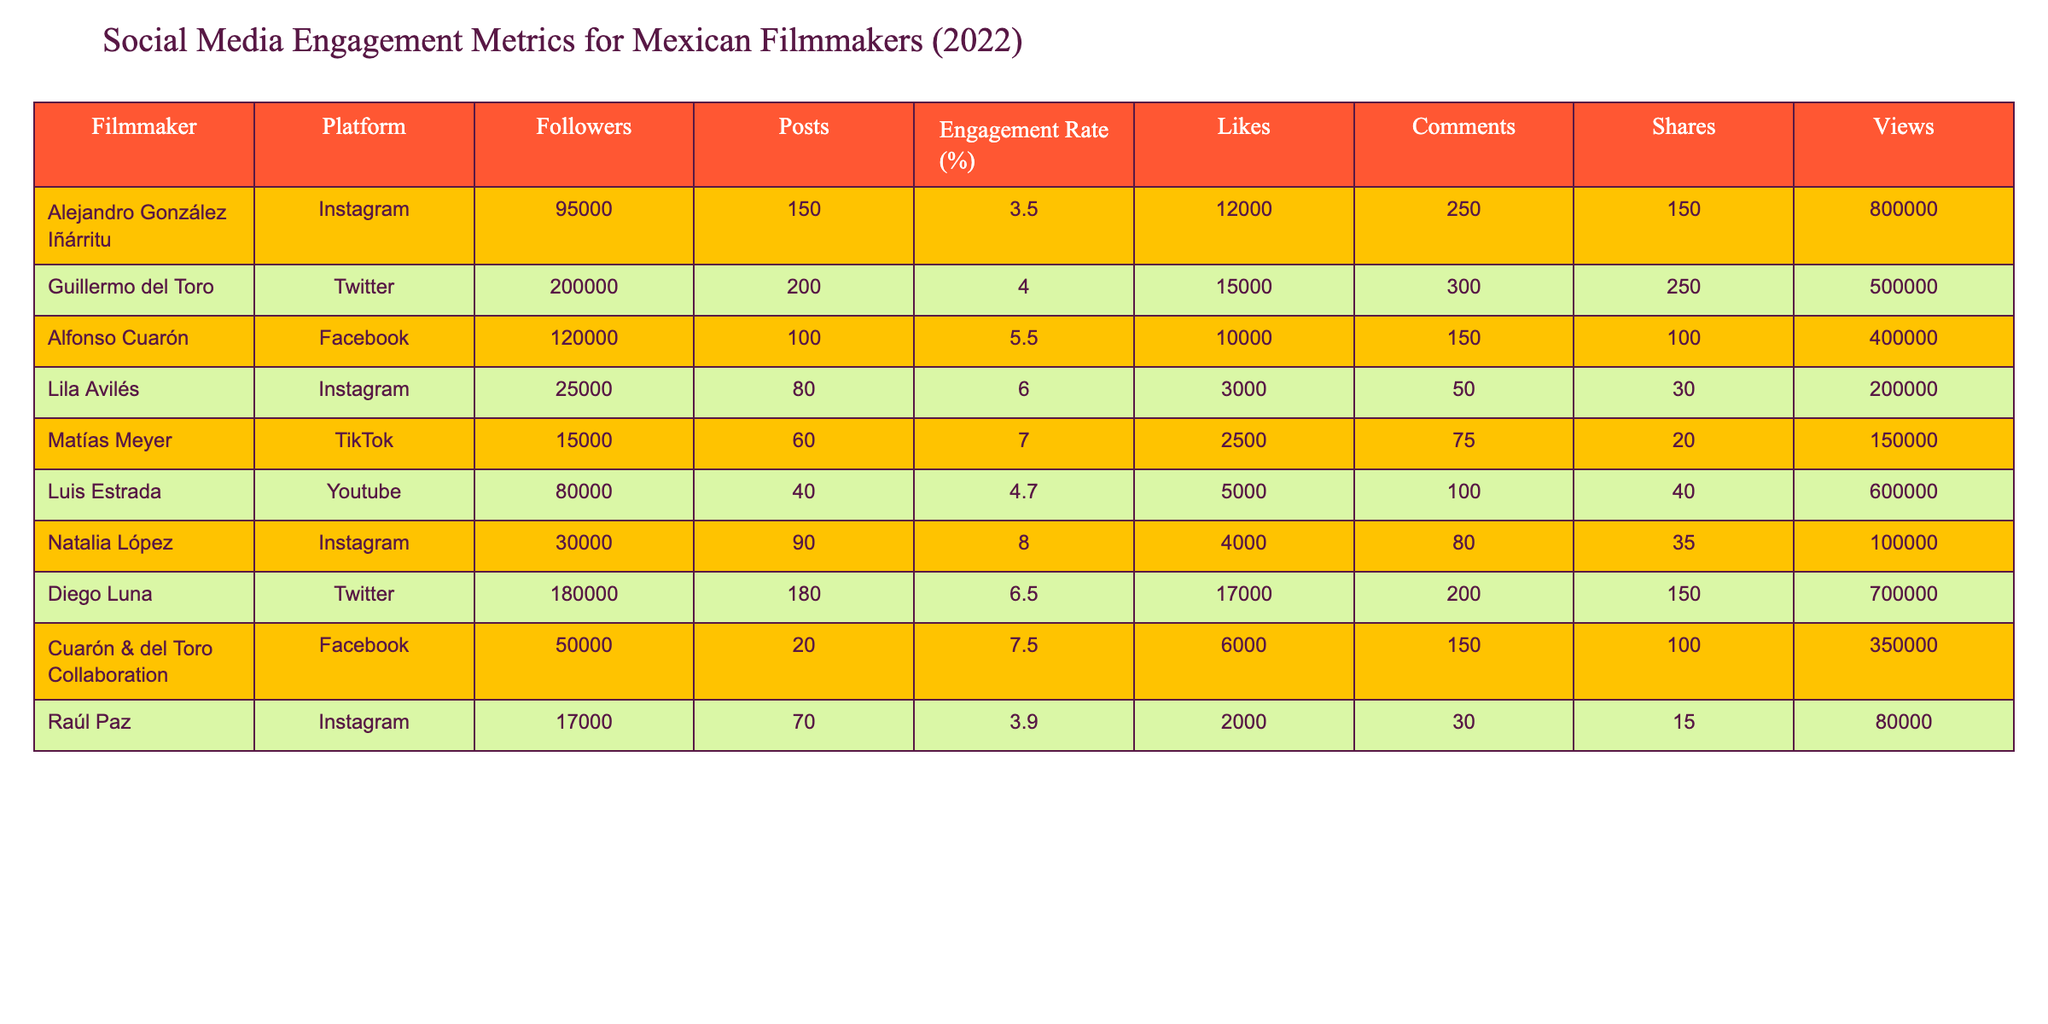What is the engagement rate for Alejandro González Iñárritu on Instagram? The table lists the engagement rate for Alejandro González Iñárritu under the Instagram platform as 3.5%.
Answer: 3.5% Which filmmaker has the highest number of followers on Twitter? The table indicates that Guillermo del Toro has 200,000 followers on Twitter, which is higher than any other filmmaker listed.
Answer: Guillermo del Toro What is the total number of posts made by all filmmakers on Instagram? From the data provided, Alejandro González Iñárritu has 150 posts, Lila Avilés has 80 posts, and Natalia López has 90 posts. Adding these gives a total of 150 + 80 + 90 = 320 posts.
Answer: 320 Is there any filmmaker in the table who has more than 150 shares? By reviewing the shares column, only Guillermo del Toro has 250 shares, while others have less than that. Thus, there is at least one filmmaker with more than 150 shares.
Answer: Yes What is the average engagement rate for all filmmakers listed in the table? The engagement rates are 3.5, 4.0, 5.5, 6.0, 7.0, 4.7, 8.0, 6.5, 7.5, and 3.9. Adding these gives a total of 57.6, and dividing by 10 (the number of filmmakers) results in an average engagement rate of 5.76%.
Answer: 5.76% Which filmmaker had the least number of views and how many did they have? By scanning the views column, Raúl Paz has the lowest count of 80,000 views compared to the others.
Answer: Raúl Paz, 80,000 views How many more likes did Diego Luna receive compared to Lila Avilés? Diego Luna received 17,000 likes while Lila Avilés received 3,000 likes. The difference is 17,000 - 3,000 = 14,000 likes.
Answer: 14,000 What percentage of total engagement does Cuarón & del Toro Collaboration have relative to Diego Luna's total engagement? Diego Luna has a total engagement (likes + comments + shares) of 17,000 + 200 + 150 = 17,350. Cuarón & del Toro Collaboration has 6,000 + 150 + 100 = 6,250. The percentage is (6,250 / 17,350) * 100 = approximately 36.1%.
Answer: 36.1% Who is the filmmaker with the lowest engagement rate among those listed? The engagement rates are 3.5, 4.0, 5.5, 6.0, 7.0, 4.7, 8.0, 6.5, 7.5, and 3.9. The lowest engagement rate is 3.5, corresponding to Alejandro González Iñárritu.
Answer: Alejandro González Iñárritu How many filmmakers have engagement rates greater than 6%? The engagement rates above 6% are 6.0, 7.0, 8.0, 6.5, and 7.5. Counting these gives a total of 5 filmmakers.
Answer: 5 filmmakers 